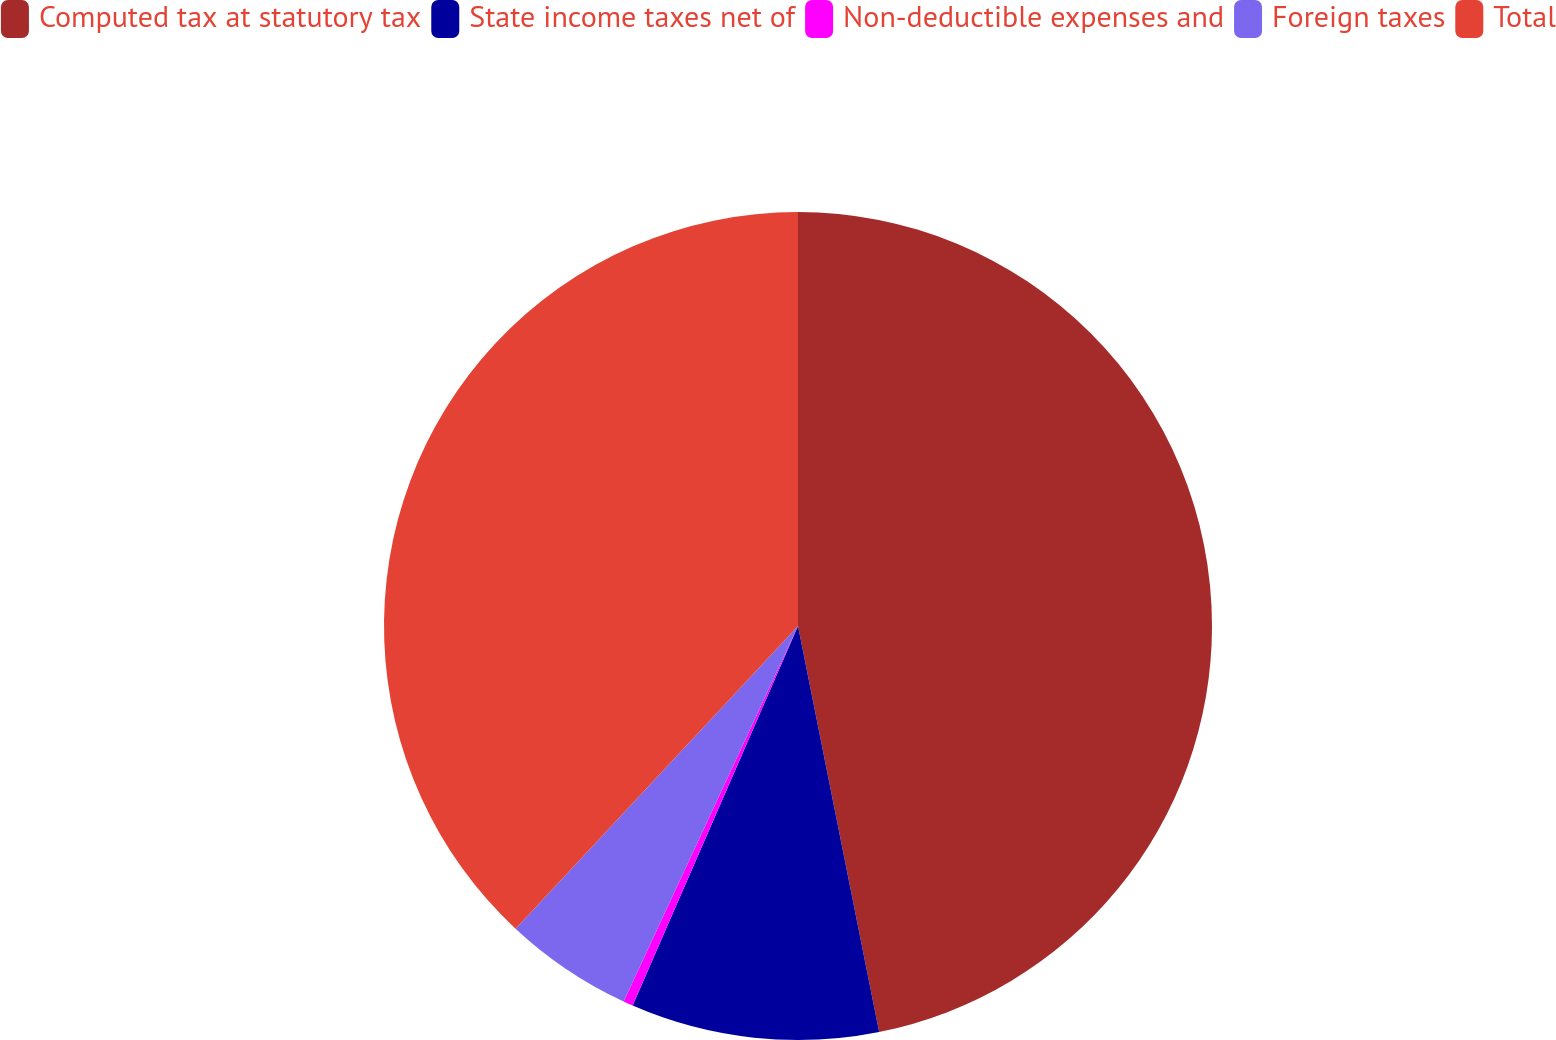<chart> <loc_0><loc_0><loc_500><loc_500><pie_chart><fcel>Computed tax at statutory tax<fcel>State income taxes net of<fcel>Non-deductible expenses and<fcel>Foreign taxes<fcel>Total<nl><fcel>46.86%<fcel>9.68%<fcel>0.38%<fcel>5.03%<fcel>38.05%<nl></chart> 